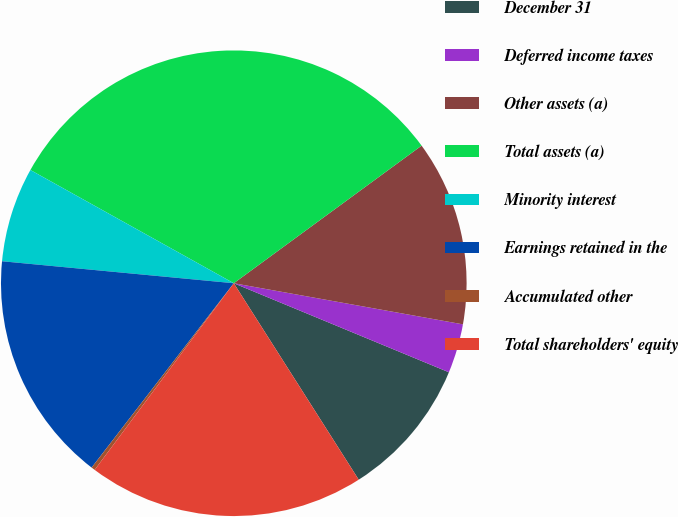Convert chart. <chart><loc_0><loc_0><loc_500><loc_500><pie_chart><fcel>December 31<fcel>Deferred income taxes<fcel>Other assets (a)<fcel>Total assets (a)<fcel>Minority interest<fcel>Earnings retained in the<fcel>Accumulated other<fcel>Total shareholders' equity<nl><fcel>9.74%<fcel>3.42%<fcel>12.89%<fcel>31.85%<fcel>6.58%<fcel>16.05%<fcel>0.26%<fcel>19.21%<nl></chart> 